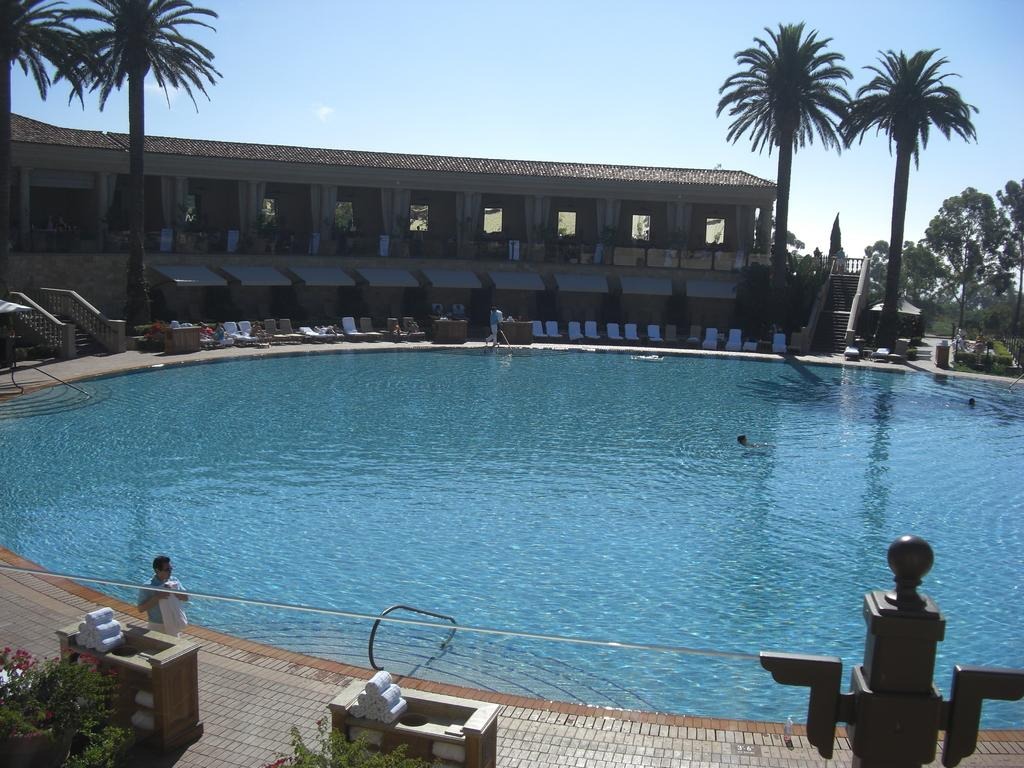What is the main feature in the image? There is a swimming pool in the image. What are the people around the swimming pool doing? People are sitting on chairs around the swimming pool. What can be seen in the background of the image? There is a building and trees in the background of the image. What type of lock is used to secure the swimming pool in the image? There is no lock present in the image, as swimming pools are typically not secured with locks. 